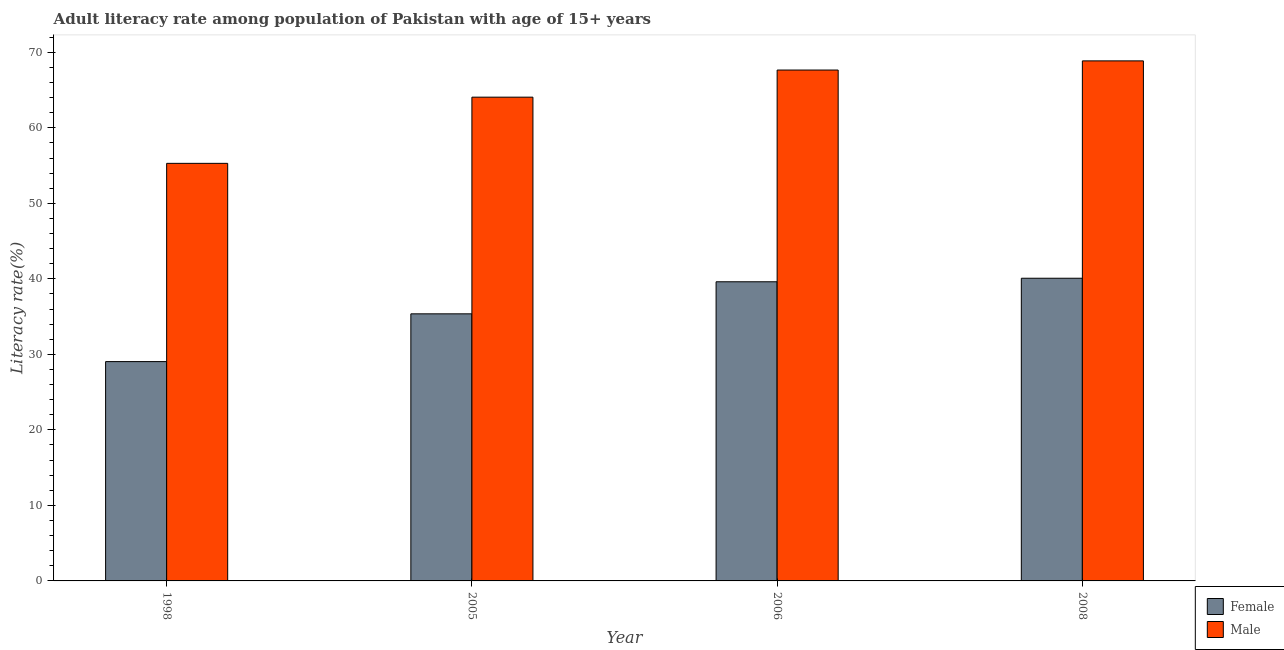How many different coloured bars are there?
Provide a succinct answer. 2. What is the male adult literacy rate in 2006?
Provide a short and direct response. 67.65. Across all years, what is the maximum male adult literacy rate?
Provide a short and direct response. 68.87. Across all years, what is the minimum female adult literacy rate?
Provide a succinct answer. 29.04. In which year was the female adult literacy rate maximum?
Your response must be concise. 2008. What is the total female adult literacy rate in the graph?
Make the answer very short. 144.11. What is the difference between the male adult literacy rate in 2005 and that in 2006?
Keep it short and to the point. -3.59. What is the difference between the female adult literacy rate in 2005 and the male adult literacy rate in 1998?
Provide a short and direct response. 6.32. What is the average male adult literacy rate per year?
Offer a very short reply. 63.97. In how many years, is the male adult literacy rate greater than 48 %?
Your answer should be compact. 4. What is the ratio of the female adult literacy rate in 1998 to that in 2008?
Make the answer very short. 0.72. What is the difference between the highest and the second highest male adult literacy rate?
Give a very brief answer. 1.21. What is the difference between the highest and the lowest male adult literacy rate?
Your response must be concise. 13.57. In how many years, is the male adult literacy rate greater than the average male adult literacy rate taken over all years?
Your answer should be compact. 3. Is the sum of the female adult literacy rate in 1998 and 2006 greater than the maximum male adult literacy rate across all years?
Offer a very short reply. Yes. What does the 2nd bar from the right in 2006 represents?
Provide a short and direct response. Female. How many bars are there?
Provide a succinct answer. 8. What is the difference between two consecutive major ticks on the Y-axis?
Your response must be concise. 10. Does the graph contain grids?
Make the answer very short. No. How are the legend labels stacked?
Ensure brevity in your answer.  Vertical. What is the title of the graph?
Offer a terse response. Adult literacy rate among population of Pakistan with age of 15+ years. Does "Male entrants" appear as one of the legend labels in the graph?
Keep it short and to the point. No. What is the label or title of the X-axis?
Your answer should be compact. Year. What is the label or title of the Y-axis?
Your answer should be very brief. Literacy rate(%). What is the Literacy rate(%) of Female in 1998?
Your answer should be compact. 29.04. What is the Literacy rate(%) in Male in 1998?
Ensure brevity in your answer.  55.3. What is the Literacy rate(%) of Female in 2005?
Provide a short and direct response. 35.37. What is the Literacy rate(%) in Male in 2005?
Make the answer very short. 64.06. What is the Literacy rate(%) in Female in 2006?
Ensure brevity in your answer.  39.61. What is the Literacy rate(%) of Male in 2006?
Offer a very short reply. 67.65. What is the Literacy rate(%) in Female in 2008?
Your answer should be very brief. 40.08. What is the Literacy rate(%) of Male in 2008?
Your answer should be compact. 68.87. Across all years, what is the maximum Literacy rate(%) in Female?
Your response must be concise. 40.08. Across all years, what is the maximum Literacy rate(%) of Male?
Your answer should be very brief. 68.87. Across all years, what is the minimum Literacy rate(%) of Female?
Offer a terse response. 29.04. Across all years, what is the minimum Literacy rate(%) in Male?
Provide a succinct answer. 55.3. What is the total Literacy rate(%) in Female in the graph?
Provide a short and direct response. 144.11. What is the total Literacy rate(%) in Male in the graph?
Provide a short and direct response. 255.88. What is the difference between the Literacy rate(%) of Female in 1998 and that in 2005?
Make the answer very short. -6.32. What is the difference between the Literacy rate(%) in Male in 1998 and that in 2005?
Offer a very short reply. -8.76. What is the difference between the Literacy rate(%) in Female in 1998 and that in 2006?
Provide a short and direct response. -10.57. What is the difference between the Literacy rate(%) in Male in 1998 and that in 2006?
Offer a very short reply. -12.36. What is the difference between the Literacy rate(%) of Female in 1998 and that in 2008?
Offer a very short reply. -11.04. What is the difference between the Literacy rate(%) in Male in 1998 and that in 2008?
Your response must be concise. -13.57. What is the difference between the Literacy rate(%) in Female in 2005 and that in 2006?
Ensure brevity in your answer.  -4.25. What is the difference between the Literacy rate(%) of Male in 2005 and that in 2006?
Provide a succinct answer. -3.59. What is the difference between the Literacy rate(%) of Female in 2005 and that in 2008?
Provide a succinct answer. -4.71. What is the difference between the Literacy rate(%) of Male in 2005 and that in 2008?
Provide a short and direct response. -4.81. What is the difference between the Literacy rate(%) of Female in 2006 and that in 2008?
Offer a very short reply. -0.47. What is the difference between the Literacy rate(%) of Male in 2006 and that in 2008?
Your response must be concise. -1.21. What is the difference between the Literacy rate(%) of Female in 1998 and the Literacy rate(%) of Male in 2005?
Offer a terse response. -35.02. What is the difference between the Literacy rate(%) in Female in 1998 and the Literacy rate(%) in Male in 2006?
Your response must be concise. -38.61. What is the difference between the Literacy rate(%) of Female in 1998 and the Literacy rate(%) of Male in 2008?
Ensure brevity in your answer.  -39.82. What is the difference between the Literacy rate(%) of Female in 2005 and the Literacy rate(%) of Male in 2006?
Your answer should be very brief. -32.28. What is the difference between the Literacy rate(%) in Female in 2005 and the Literacy rate(%) in Male in 2008?
Ensure brevity in your answer.  -33.5. What is the difference between the Literacy rate(%) of Female in 2006 and the Literacy rate(%) of Male in 2008?
Give a very brief answer. -29.25. What is the average Literacy rate(%) of Female per year?
Your answer should be compact. 36.03. What is the average Literacy rate(%) in Male per year?
Your answer should be very brief. 63.97. In the year 1998, what is the difference between the Literacy rate(%) in Female and Literacy rate(%) in Male?
Ensure brevity in your answer.  -26.25. In the year 2005, what is the difference between the Literacy rate(%) in Female and Literacy rate(%) in Male?
Your answer should be compact. -28.69. In the year 2006, what is the difference between the Literacy rate(%) of Female and Literacy rate(%) of Male?
Provide a short and direct response. -28.04. In the year 2008, what is the difference between the Literacy rate(%) of Female and Literacy rate(%) of Male?
Offer a terse response. -28.78. What is the ratio of the Literacy rate(%) in Female in 1998 to that in 2005?
Provide a succinct answer. 0.82. What is the ratio of the Literacy rate(%) of Male in 1998 to that in 2005?
Ensure brevity in your answer.  0.86. What is the ratio of the Literacy rate(%) in Female in 1998 to that in 2006?
Your answer should be very brief. 0.73. What is the ratio of the Literacy rate(%) in Male in 1998 to that in 2006?
Your answer should be very brief. 0.82. What is the ratio of the Literacy rate(%) of Female in 1998 to that in 2008?
Offer a terse response. 0.72. What is the ratio of the Literacy rate(%) of Male in 1998 to that in 2008?
Make the answer very short. 0.8. What is the ratio of the Literacy rate(%) of Female in 2005 to that in 2006?
Offer a terse response. 0.89. What is the ratio of the Literacy rate(%) of Male in 2005 to that in 2006?
Your response must be concise. 0.95. What is the ratio of the Literacy rate(%) of Female in 2005 to that in 2008?
Your answer should be very brief. 0.88. What is the ratio of the Literacy rate(%) in Male in 2005 to that in 2008?
Ensure brevity in your answer.  0.93. What is the ratio of the Literacy rate(%) of Female in 2006 to that in 2008?
Your answer should be compact. 0.99. What is the ratio of the Literacy rate(%) in Male in 2006 to that in 2008?
Make the answer very short. 0.98. What is the difference between the highest and the second highest Literacy rate(%) in Female?
Make the answer very short. 0.47. What is the difference between the highest and the second highest Literacy rate(%) in Male?
Ensure brevity in your answer.  1.21. What is the difference between the highest and the lowest Literacy rate(%) of Female?
Provide a succinct answer. 11.04. What is the difference between the highest and the lowest Literacy rate(%) of Male?
Offer a very short reply. 13.57. 